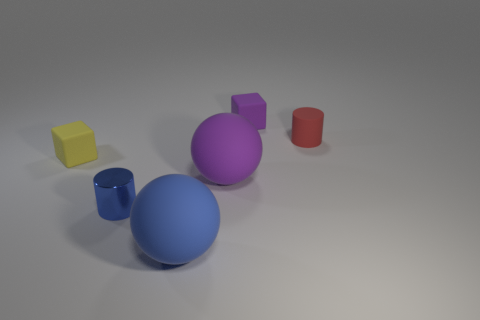How many objects are blue matte spheres or matte cubes behind the tiny yellow thing?
Offer a very short reply. 2. Are there fewer metal cylinders than tiny red metallic spheres?
Ensure brevity in your answer.  No. What color is the big ball that is in front of the purple thing that is in front of the rubber block to the right of the big purple rubber sphere?
Your answer should be very brief. Blue. Is the material of the blue ball the same as the big purple ball?
Provide a succinct answer. Yes. What number of tiny matte blocks are right of the yellow matte cube?
Make the answer very short. 1. What size is the purple matte thing that is the same shape as the yellow thing?
Offer a terse response. Small. What number of red objects are either tiny metal blocks or tiny matte objects?
Your answer should be compact. 1. There is a tiny cylinder behind the yellow block; how many rubber balls are left of it?
Your answer should be very brief. 2. How many other objects are there of the same shape as the yellow thing?
Ensure brevity in your answer.  1. What number of matte balls are the same color as the tiny metallic object?
Offer a very short reply. 1. 